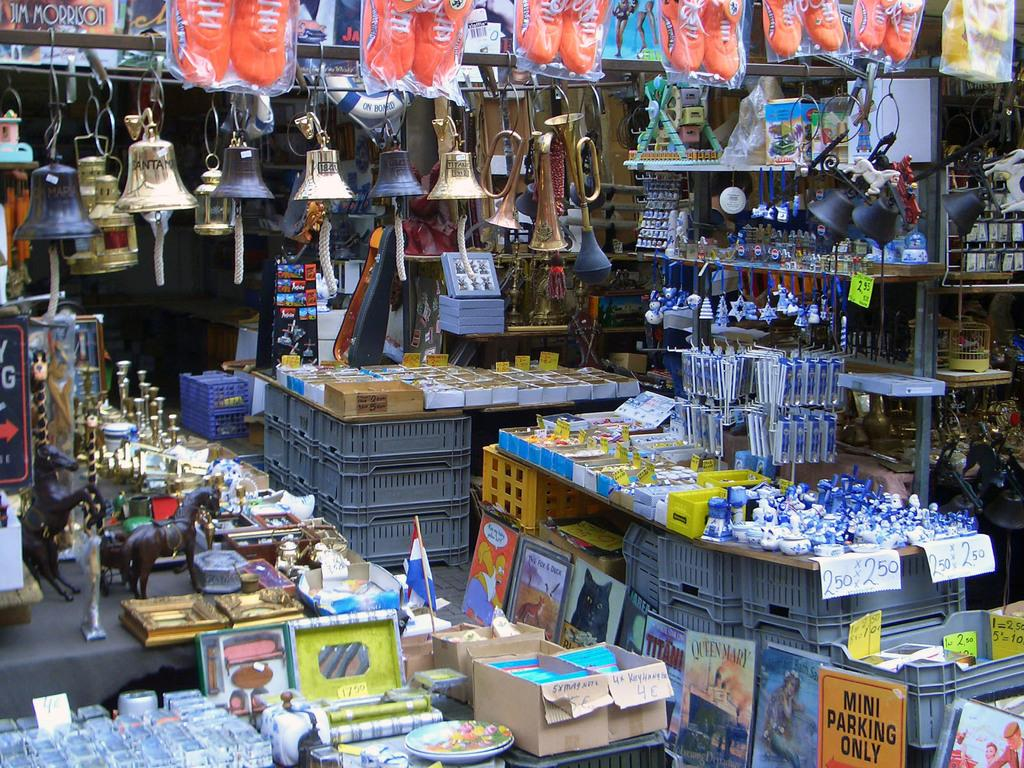Provide a one-sentence caption for the provided image. Among other items sold in this booth are a sign that advertises the Queen Mary and another featuring Homer Simpson. 